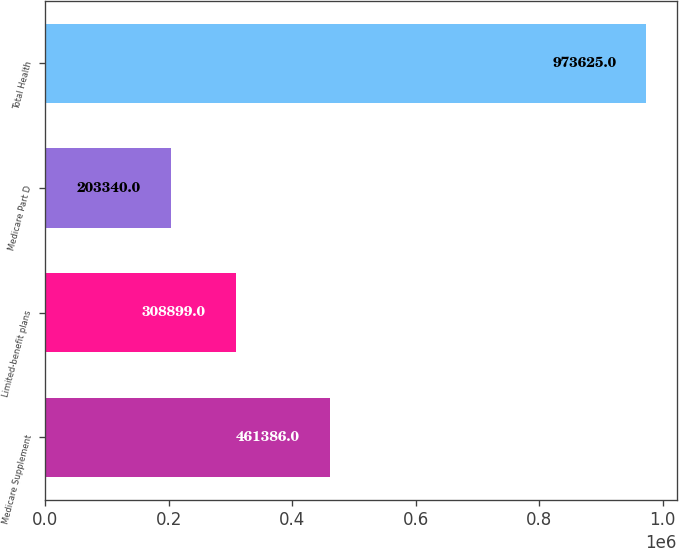Convert chart. <chart><loc_0><loc_0><loc_500><loc_500><bar_chart><fcel>Medicare Supplement<fcel>Limited-benefit plans<fcel>Medicare Part D<fcel>Total Health<nl><fcel>461386<fcel>308899<fcel>203340<fcel>973625<nl></chart> 